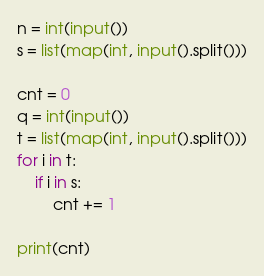<code> <loc_0><loc_0><loc_500><loc_500><_Python_>n = int(input())
s = list(map(int, input().split()))

cnt = 0
q = int(input())
t = list(map(int, input().split()))
for i in t:
    if i in s:
        cnt += 1

print(cnt)

</code> 